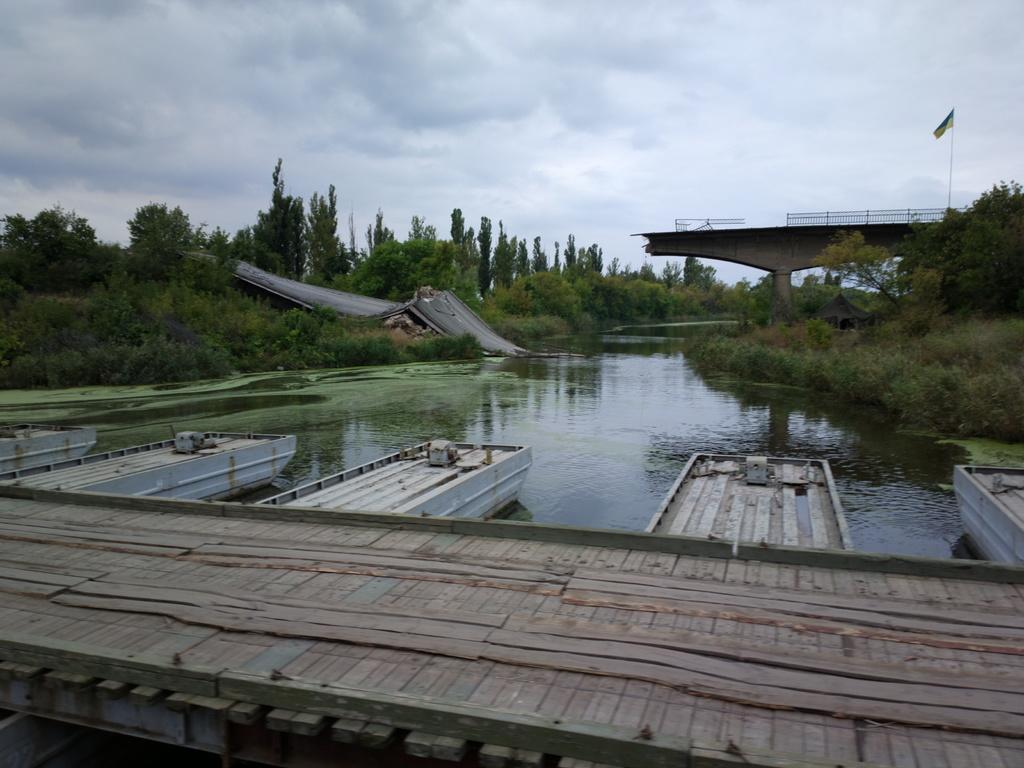In one or two sentences, can you explain what this image depicts? In this image we can see two bridges, there are some trees, water, fence and a flag, in the background we can see the sky with clouds. 